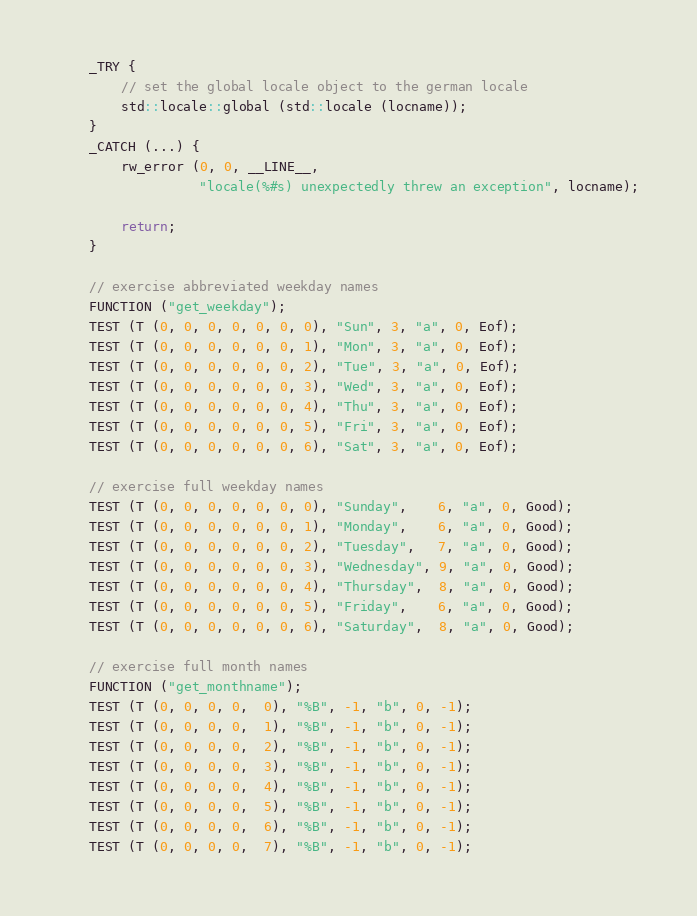Convert code to text. <code><loc_0><loc_0><loc_500><loc_500><_C++_>    _TRY {
        // set the global locale object to the german locale
        std::locale::global (std::locale (locname));
    }
    _CATCH (...) {
        rw_error (0, 0, __LINE__,
                  "locale(%#s) unexpectedly threw an exception", locname);

        return;
    }

    // exercise abbreviated weekday names
    FUNCTION ("get_weekday");
    TEST (T (0, 0, 0, 0, 0, 0, 0), "Sun", 3, "a", 0, Eof);
    TEST (T (0, 0, 0, 0, 0, 0, 1), "Mon", 3, "a", 0, Eof);
    TEST (T (0, 0, 0, 0, 0, 0, 2), "Tue", 3, "a", 0, Eof);
    TEST (T (0, 0, 0, 0, 0, 0, 3), "Wed", 3, "a", 0, Eof);
    TEST (T (0, 0, 0, 0, 0, 0, 4), "Thu", 3, "a", 0, Eof);
    TEST (T (0, 0, 0, 0, 0, 0, 5), "Fri", 3, "a", 0, Eof);
    TEST (T (0, 0, 0, 0, 0, 0, 6), "Sat", 3, "a", 0, Eof);

    // exercise full weekday names
    TEST (T (0, 0, 0, 0, 0, 0, 0), "Sunday",    6, "a", 0, Good);
    TEST (T (0, 0, 0, 0, 0, 0, 1), "Monday",    6, "a", 0, Good);
    TEST (T (0, 0, 0, 0, 0, 0, 2), "Tuesday",   7, "a", 0, Good);
    TEST (T (0, 0, 0, 0, 0, 0, 3), "Wednesday", 9, "a", 0, Good);
    TEST (T (0, 0, 0, 0, 0, 0, 4), "Thursday",  8, "a", 0, Good);
    TEST (T (0, 0, 0, 0, 0, 0, 5), "Friday",    6, "a", 0, Good);
    TEST (T (0, 0, 0, 0, 0, 0, 6), "Saturday",  8, "a", 0, Good);

    // exercise full month names
    FUNCTION ("get_monthname");
    TEST (T (0, 0, 0, 0,  0), "%B", -1, "b", 0, -1);
    TEST (T (0, 0, 0, 0,  1), "%B", -1, "b", 0, -1);
    TEST (T (0, 0, 0, 0,  2), "%B", -1, "b", 0, -1);
    TEST (T (0, 0, 0, 0,  3), "%B", -1, "b", 0, -1);
    TEST (T (0, 0, 0, 0,  4), "%B", -1, "b", 0, -1);
    TEST (T (0, 0, 0, 0,  5), "%B", -1, "b", 0, -1);
    TEST (T (0, 0, 0, 0,  6), "%B", -1, "b", 0, -1);
    TEST (T (0, 0, 0, 0,  7), "%B", -1, "b", 0, -1);</code> 